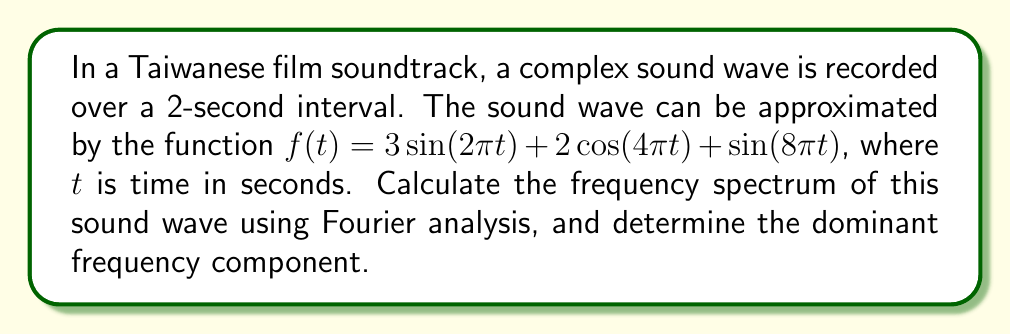Teach me how to tackle this problem. To calculate the frequency spectrum using Fourier analysis, we need to follow these steps:

1) Identify the frequency components in the given function:
   $f(t) = 3\sin(2\pi t) + 2\cos(4\pi t) + \sin(8\pi t)$

2) For each term, determine the frequency:
   - For $3\sin(2\pi t)$: $\omega_1 = 2\pi$, so $f_1 = \frac{\omega_1}{2\pi} = 1$ Hz
   - For $2\cos(4\pi t)$: $\omega_2 = 4\pi$, so $f_2 = \frac{\omega_2}{2\pi} = 2$ Hz
   - For $\sin(8\pi t)$: $\omega_3 = 8\pi$, so $f_3 = \frac{\omega_3}{2\pi} = 4$ Hz

3) Determine the amplitude of each frequency component:
   - For $f_1 = 1$ Hz: $A_1 = 3$
   - For $f_2 = 2$ Hz: $A_2 = 2$
   - For $f_3 = 4$ Hz: $A_3 = 1$

4) The frequency spectrum is represented by these frequency-amplitude pairs:
   $(1 \text{ Hz}, 3), (2 \text{ Hz}, 2), (4 \text{ Hz}, 1)$

5) The dominant frequency component is the one with the highest amplitude, which is 3 at 1 Hz.
Answer: Frequency spectrum: $(1 \text{ Hz}, 3), (2 \text{ Hz}, 2), (4 \text{ Hz}, 1)$; Dominant frequency: 1 Hz 